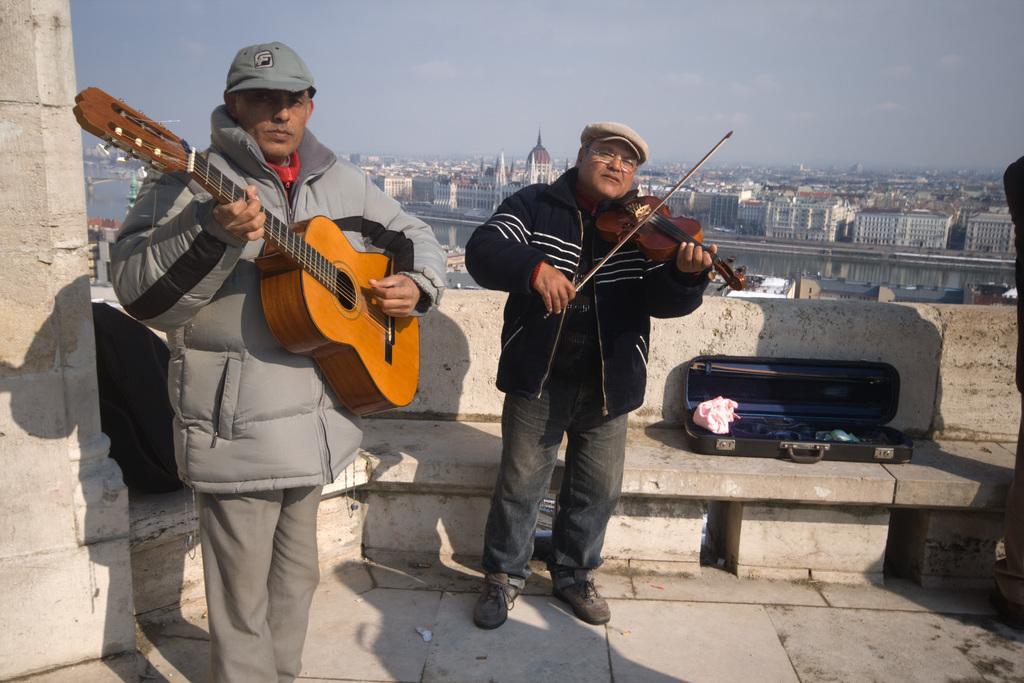Please provide a concise description of this image. Two men are standing on the floor and playing musical instruments. Behind them there are buildings,water,sky. 